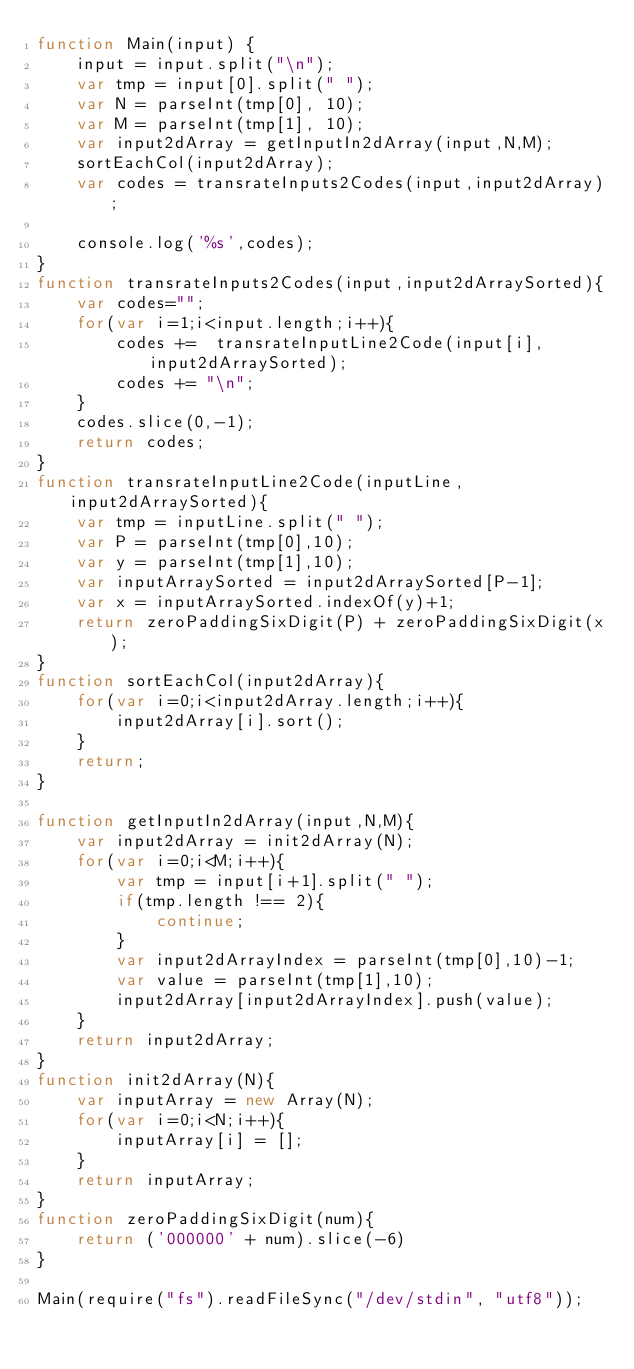Convert code to text. <code><loc_0><loc_0><loc_500><loc_500><_JavaScript_>function Main(input) {
	input = input.split("\n");
	var tmp = input[0].split(" ");
    var N = parseInt(tmp[0], 10);
    var M = parseInt(tmp[1], 10);
    var input2dArray = getInputIn2dArray(input,N,M);
    sortEachCol(input2dArray);
    var codes = transrateInputs2Codes(input,input2dArray);

	console.log('%s',codes);
}
function transrateInputs2Codes(input,input2dArraySorted){
    var codes="";
    for(var i=1;i<input.length;i++){
        codes +=  transrateInputLine2Code(input[i],input2dArraySorted);
        codes += "\n";
    }
    codes.slice(0,-1);
    return codes;
}
function transrateInputLine2Code(inputLine,input2dArraySorted){
	var tmp = inputLine.split(" ");
    var P = parseInt(tmp[0],10);
    var y = parseInt(tmp[1],10);
    var inputArraySorted = input2dArraySorted[P-1];
    var x = inputArraySorted.indexOf(y)+1;
    return zeroPaddingSixDigit(P) + zeroPaddingSixDigit(x);
}
function sortEachCol(input2dArray){
    for(var i=0;i<input2dArray.length;i++){
        input2dArray[i].sort();
    }
    return;
}

function getInputIn2dArray(input,N,M){
    var input2dArray = init2dArray(N);
    for(var i=0;i<M;i++){
	    var tmp = input[i+1].split(" ");
        if(tmp.length !== 2){
            continue;
        }
        var input2dArrayIndex = parseInt(tmp[0],10)-1;
        var value = parseInt(tmp[1],10);
        input2dArray[input2dArrayIndex].push(value);
    }
    return input2dArray;
}
function init2dArray(N){
    var inputArray = new Array(N);
    for(var i=0;i<N;i++){
        inputArray[i] = [];
    }
    return inputArray;
}
function zeroPaddingSixDigit(num){
    return ('000000' + num).slice(-6)
}

Main(require("fs").readFileSync("/dev/stdin", "utf8"));</code> 